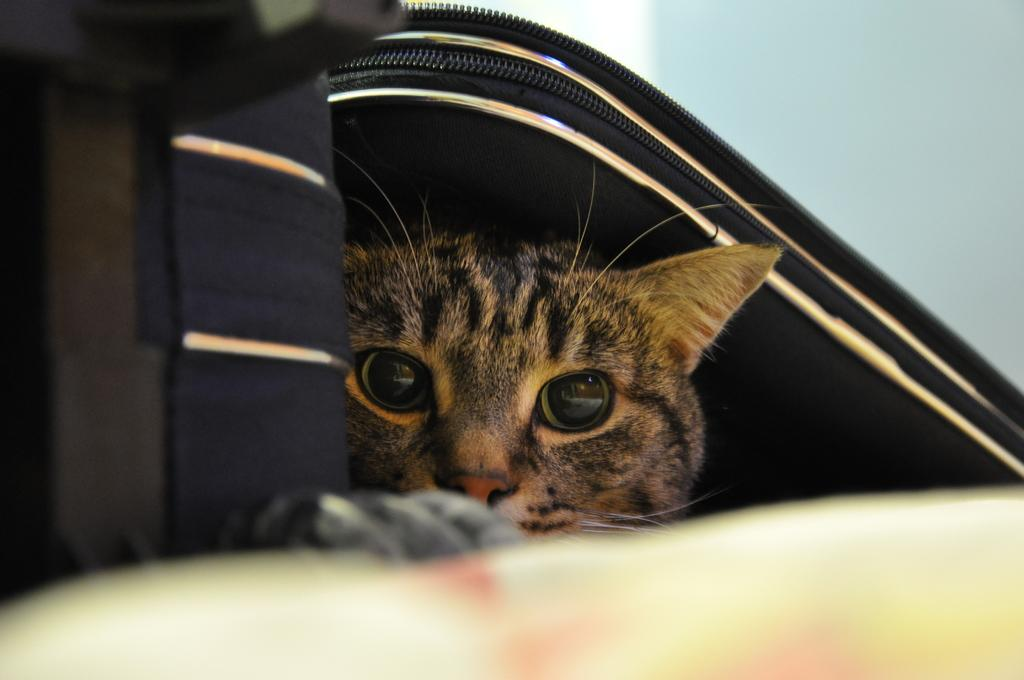What type of bag is shown in the image? There is a bag with a zip in the image. What is located under the bag? A cat is visible under the bag. What can be seen behind the bag? There is a wall behind the bag. What type of yoke is visible in the image? There is no yoke present in the image. How does the cat's body stretch under the bag? The image does not show the cat's body stretching; it only shows the cat under the bag. 